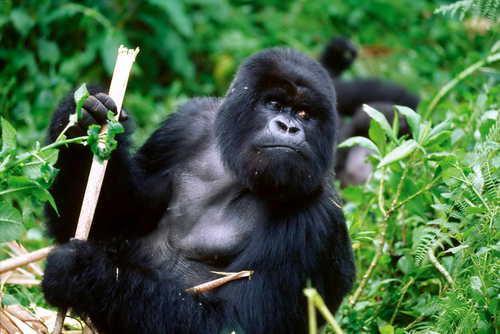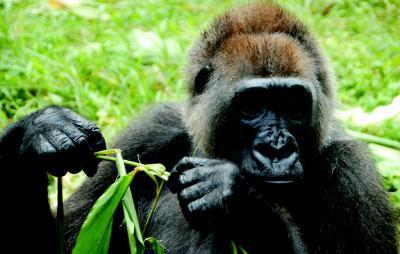The first image is the image on the left, the second image is the image on the right. Evaluate the accuracy of this statement regarding the images: "The primate in the image on the left is an adult, and there is at least one baby primate in the image on the right.". Is it true? Answer yes or no. No. 